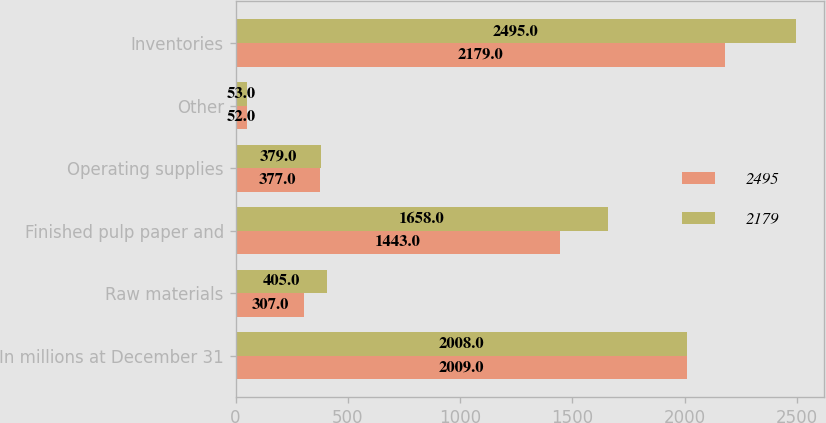Convert chart. <chart><loc_0><loc_0><loc_500><loc_500><stacked_bar_chart><ecel><fcel>In millions at December 31<fcel>Raw materials<fcel>Finished pulp paper and<fcel>Operating supplies<fcel>Other<fcel>Inventories<nl><fcel>2495<fcel>2009<fcel>307<fcel>1443<fcel>377<fcel>52<fcel>2179<nl><fcel>2179<fcel>2008<fcel>405<fcel>1658<fcel>379<fcel>53<fcel>2495<nl></chart> 